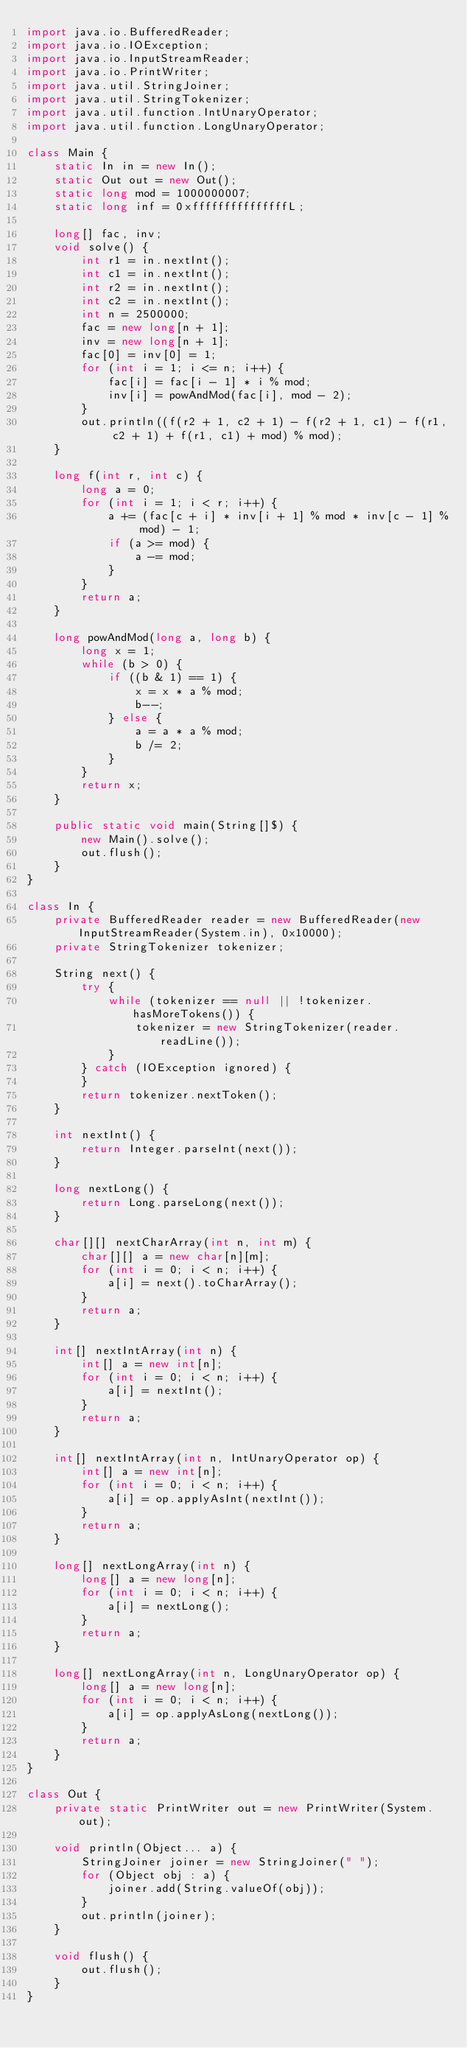Convert code to text. <code><loc_0><loc_0><loc_500><loc_500><_Java_>import java.io.BufferedReader;
import java.io.IOException;
import java.io.InputStreamReader;
import java.io.PrintWriter;
import java.util.StringJoiner;
import java.util.StringTokenizer;
import java.util.function.IntUnaryOperator;
import java.util.function.LongUnaryOperator;

class Main {
    static In in = new In();
    static Out out = new Out();
    static long mod = 1000000007;
    static long inf = 0xfffffffffffffffL;

    long[] fac, inv;
    void solve() {
        int r1 = in.nextInt();
        int c1 = in.nextInt();
        int r2 = in.nextInt();
        int c2 = in.nextInt();
        int n = 2500000;
        fac = new long[n + 1];
        inv = new long[n + 1];
        fac[0] = inv[0] = 1;
        for (int i = 1; i <= n; i++) {
            fac[i] = fac[i - 1] * i % mod;
            inv[i] = powAndMod(fac[i], mod - 2);
        }
        out.println((f(r2 + 1, c2 + 1) - f(r2 + 1, c1) - f(r1, c2 + 1) + f(r1, c1) + mod) % mod);
    }

    long f(int r, int c) {
        long a = 0;
        for (int i = 1; i < r; i++) {
            a += (fac[c + i] * inv[i + 1] % mod * inv[c - 1] % mod) - 1;
            if (a >= mod) {
                a -= mod;
            }
        }
        return a;
    }

    long powAndMod(long a, long b) {
        long x = 1;
        while (b > 0) {
            if ((b & 1) == 1) {
                x = x * a % mod;
                b--;
            } else {
                a = a * a % mod;
                b /= 2;
            }
        }
        return x;
    }

    public static void main(String[]$) {
        new Main().solve();
        out.flush();
    }
}

class In {
    private BufferedReader reader = new BufferedReader(new InputStreamReader(System.in), 0x10000);
    private StringTokenizer tokenizer;

    String next() {
        try {
            while (tokenizer == null || !tokenizer.hasMoreTokens()) {
                tokenizer = new StringTokenizer(reader.readLine());
            }
        } catch (IOException ignored) {
        }
        return tokenizer.nextToken();
    }

    int nextInt() {
        return Integer.parseInt(next());
    }

    long nextLong() {
        return Long.parseLong(next());
    }

    char[][] nextCharArray(int n, int m) {
        char[][] a = new char[n][m];
        for (int i = 0; i < n; i++) {
            a[i] = next().toCharArray();
        }
        return a;
    }

    int[] nextIntArray(int n) {
        int[] a = new int[n];
        for (int i = 0; i < n; i++) {
            a[i] = nextInt();
        }
        return a;
    }

    int[] nextIntArray(int n, IntUnaryOperator op) {
        int[] a = new int[n];
        for (int i = 0; i < n; i++) {
            a[i] = op.applyAsInt(nextInt());
        }
        return a;
    }

    long[] nextLongArray(int n) {
        long[] a = new long[n];
        for (int i = 0; i < n; i++) {
            a[i] = nextLong();
        }
        return a;
    }

    long[] nextLongArray(int n, LongUnaryOperator op) {
        long[] a = new long[n];
        for (int i = 0; i < n; i++) {
            a[i] = op.applyAsLong(nextLong());
        }
        return a;
    }
}

class Out {
    private static PrintWriter out = new PrintWriter(System.out);

    void println(Object... a) {
        StringJoiner joiner = new StringJoiner(" ");
        for (Object obj : a) {
            joiner.add(String.valueOf(obj));
        }
        out.println(joiner);
    }

    void flush() {
        out.flush();
    }
}
</code> 